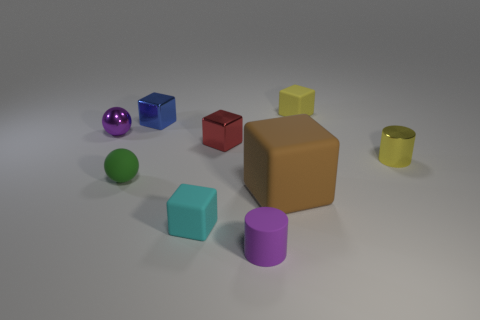How many big blue things have the same shape as the tiny yellow rubber object?
Give a very brief answer. 0. There is a purple thing that is the same material as the large brown block; what is its size?
Provide a short and direct response. Small. Is the number of large matte things greater than the number of green cylinders?
Offer a terse response. Yes. There is a rubber block behind the green rubber thing; what color is it?
Your response must be concise. Yellow. How big is the matte block that is on the right side of the tiny red object and in front of the purple metal thing?
Your response must be concise. Large. How many gray balls have the same size as the yellow metallic object?
Provide a short and direct response. 0. There is a tiny blue thing that is the same shape as the small red thing; what is it made of?
Keep it short and to the point. Metal. Does the green matte thing have the same shape as the purple matte thing?
Offer a very short reply. No. There is a small red block; what number of matte cubes are on the right side of it?
Offer a very short reply. 2. What is the shape of the small matte thing behind the tiny metal object on the left side of the matte sphere?
Your answer should be very brief. Cube. 